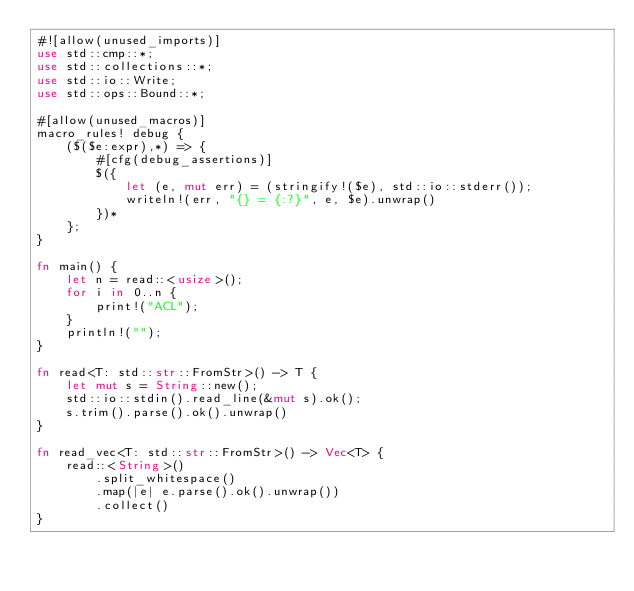<code> <loc_0><loc_0><loc_500><loc_500><_Rust_>#![allow(unused_imports)]
use std::cmp::*;
use std::collections::*;
use std::io::Write;
use std::ops::Bound::*;

#[allow(unused_macros)]
macro_rules! debug {
    ($($e:expr),*) => {
        #[cfg(debug_assertions)]
        $({
            let (e, mut err) = (stringify!($e), std::io::stderr());
            writeln!(err, "{} = {:?}", e, $e).unwrap()
        })*
    };
}

fn main() {
    let n = read::<usize>();
    for i in 0..n {
        print!("ACL");
    }
    println!("");
}

fn read<T: std::str::FromStr>() -> T {
    let mut s = String::new();
    std::io::stdin().read_line(&mut s).ok();
    s.trim().parse().ok().unwrap()
}

fn read_vec<T: std::str::FromStr>() -> Vec<T> {
    read::<String>()
        .split_whitespace()
        .map(|e| e.parse().ok().unwrap())
        .collect()
}
</code> 